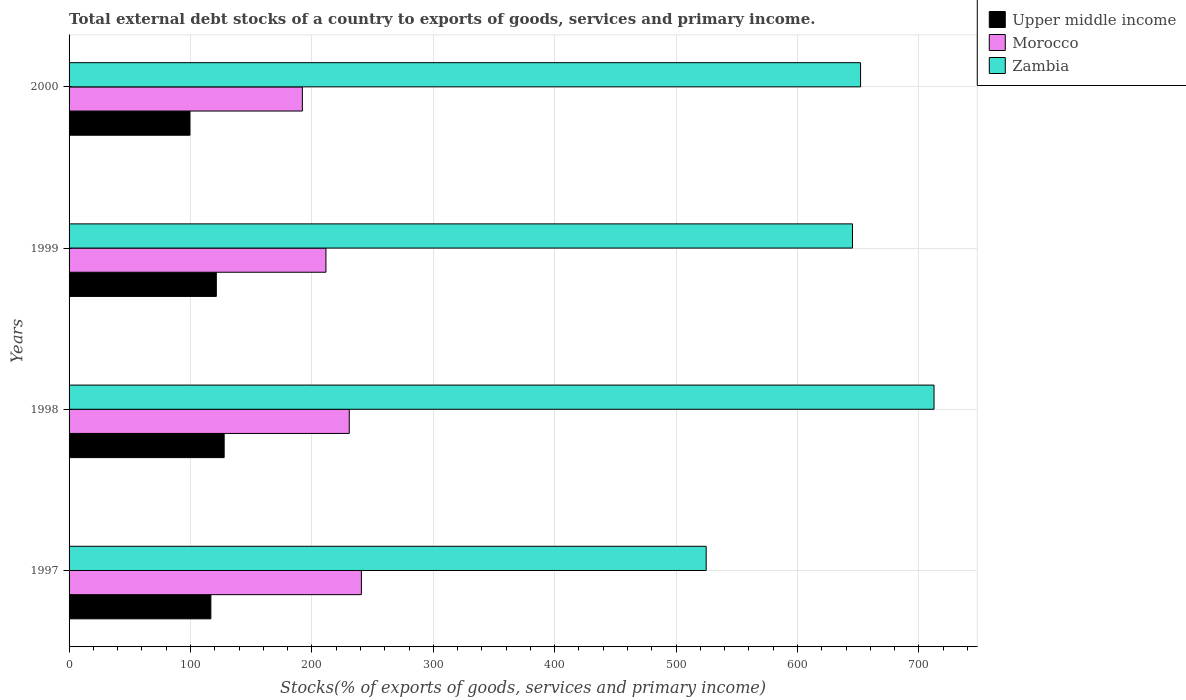How many different coloured bars are there?
Ensure brevity in your answer.  3. How many groups of bars are there?
Make the answer very short. 4. How many bars are there on the 3rd tick from the top?
Offer a very short reply. 3. How many bars are there on the 1st tick from the bottom?
Give a very brief answer. 3. What is the label of the 2nd group of bars from the top?
Provide a succinct answer. 1999. What is the total debt stocks in Morocco in 2000?
Your response must be concise. 192.17. Across all years, what is the maximum total debt stocks in Upper middle income?
Provide a short and direct response. 127.75. Across all years, what is the minimum total debt stocks in Zambia?
Ensure brevity in your answer.  524.81. In which year was the total debt stocks in Morocco maximum?
Your answer should be compact. 1997. In which year was the total debt stocks in Morocco minimum?
Provide a short and direct response. 2000. What is the total total debt stocks in Upper middle income in the graph?
Give a very brief answer. 465.4. What is the difference between the total debt stocks in Morocco in 1997 and that in 2000?
Provide a succinct answer. 48.61. What is the difference between the total debt stocks in Morocco in 2000 and the total debt stocks in Zambia in 1997?
Ensure brevity in your answer.  -332.64. What is the average total debt stocks in Morocco per year?
Keep it short and to the point. 218.83. In the year 1999, what is the difference between the total debt stocks in Morocco and total debt stocks in Zambia?
Offer a terse response. -433.74. In how many years, is the total debt stocks in Zambia greater than 140 %?
Make the answer very short. 4. What is the ratio of the total debt stocks in Morocco in 1999 to that in 2000?
Your answer should be compact. 1.1. Is the total debt stocks in Upper middle income in 1997 less than that in 1999?
Your response must be concise. Yes. What is the difference between the highest and the second highest total debt stocks in Upper middle income?
Your answer should be very brief. 6.46. What is the difference between the highest and the lowest total debt stocks in Morocco?
Offer a terse response. 48.61. In how many years, is the total debt stocks in Zambia greater than the average total debt stocks in Zambia taken over all years?
Your answer should be compact. 3. Is the sum of the total debt stocks in Zambia in 1997 and 2000 greater than the maximum total debt stocks in Upper middle income across all years?
Offer a terse response. Yes. What does the 1st bar from the top in 2000 represents?
Ensure brevity in your answer.  Zambia. What does the 1st bar from the bottom in 2000 represents?
Provide a short and direct response. Upper middle income. Are all the bars in the graph horizontal?
Your answer should be compact. Yes. How many years are there in the graph?
Provide a succinct answer. 4. What is the difference between two consecutive major ticks on the X-axis?
Make the answer very short. 100. Are the values on the major ticks of X-axis written in scientific E-notation?
Provide a succinct answer. No. Does the graph contain any zero values?
Offer a very short reply. No. Does the graph contain grids?
Ensure brevity in your answer.  Yes. Where does the legend appear in the graph?
Your answer should be compact. Top right. What is the title of the graph?
Provide a succinct answer. Total external debt stocks of a country to exports of goods, services and primary income. What is the label or title of the X-axis?
Provide a succinct answer. Stocks(% of exports of goods, services and primary income). What is the Stocks(% of exports of goods, services and primary income) of Upper middle income in 1997?
Offer a very short reply. 116.79. What is the Stocks(% of exports of goods, services and primary income) of Morocco in 1997?
Offer a very short reply. 240.78. What is the Stocks(% of exports of goods, services and primary income) in Zambia in 1997?
Provide a short and direct response. 524.81. What is the Stocks(% of exports of goods, services and primary income) in Upper middle income in 1998?
Offer a terse response. 127.75. What is the Stocks(% of exports of goods, services and primary income) in Morocco in 1998?
Provide a succinct answer. 230.8. What is the Stocks(% of exports of goods, services and primary income) of Zambia in 1998?
Your response must be concise. 712.48. What is the Stocks(% of exports of goods, services and primary income) of Upper middle income in 1999?
Provide a succinct answer. 121.29. What is the Stocks(% of exports of goods, services and primary income) of Morocco in 1999?
Offer a terse response. 211.58. What is the Stocks(% of exports of goods, services and primary income) of Zambia in 1999?
Your answer should be very brief. 645.32. What is the Stocks(% of exports of goods, services and primary income) in Upper middle income in 2000?
Offer a very short reply. 99.57. What is the Stocks(% of exports of goods, services and primary income) in Morocco in 2000?
Offer a very short reply. 192.17. What is the Stocks(% of exports of goods, services and primary income) of Zambia in 2000?
Your answer should be compact. 651.97. Across all years, what is the maximum Stocks(% of exports of goods, services and primary income) in Upper middle income?
Ensure brevity in your answer.  127.75. Across all years, what is the maximum Stocks(% of exports of goods, services and primary income) in Morocco?
Provide a succinct answer. 240.78. Across all years, what is the maximum Stocks(% of exports of goods, services and primary income) in Zambia?
Make the answer very short. 712.48. Across all years, what is the minimum Stocks(% of exports of goods, services and primary income) in Upper middle income?
Keep it short and to the point. 99.57. Across all years, what is the minimum Stocks(% of exports of goods, services and primary income) in Morocco?
Your answer should be very brief. 192.17. Across all years, what is the minimum Stocks(% of exports of goods, services and primary income) of Zambia?
Keep it short and to the point. 524.81. What is the total Stocks(% of exports of goods, services and primary income) in Upper middle income in the graph?
Offer a terse response. 465.4. What is the total Stocks(% of exports of goods, services and primary income) in Morocco in the graph?
Offer a terse response. 875.34. What is the total Stocks(% of exports of goods, services and primary income) in Zambia in the graph?
Your response must be concise. 2534.58. What is the difference between the Stocks(% of exports of goods, services and primary income) in Upper middle income in 1997 and that in 1998?
Your answer should be very brief. -10.96. What is the difference between the Stocks(% of exports of goods, services and primary income) of Morocco in 1997 and that in 1998?
Your response must be concise. 9.99. What is the difference between the Stocks(% of exports of goods, services and primary income) in Zambia in 1997 and that in 1998?
Offer a very short reply. -187.67. What is the difference between the Stocks(% of exports of goods, services and primary income) in Upper middle income in 1997 and that in 1999?
Your response must be concise. -4.51. What is the difference between the Stocks(% of exports of goods, services and primary income) of Morocco in 1997 and that in 1999?
Your response must be concise. 29.2. What is the difference between the Stocks(% of exports of goods, services and primary income) of Zambia in 1997 and that in 1999?
Offer a terse response. -120.51. What is the difference between the Stocks(% of exports of goods, services and primary income) of Upper middle income in 1997 and that in 2000?
Provide a short and direct response. 17.22. What is the difference between the Stocks(% of exports of goods, services and primary income) of Morocco in 1997 and that in 2000?
Keep it short and to the point. 48.61. What is the difference between the Stocks(% of exports of goods, services and primary income) in Zambia in 1997 and that in 2000?
Your answer should be very brief. -127.16. What is the difference between the Stocks(% of exports of goods, services and primary income) of Upper middle income in 1998 and that in 1999?
Provide a short and direct response. 6.46. What is the difference between the Stocks(% of exports of goods, services and primary income) of Morocco in 1998 and that in 1999?
Offer a very short reply. 19.22. What is the difference between the Stocks(% of exports of goods, services and primary income) of Zambia in 1998 and that in 1999?
Keep it short and to the point. 67.16. What is the difference between the Stocks(% of exports of goods, services and primary income) in Upper middle income in 1998 and that in 2000?
Ensure brevity in your answer.  28.18. What is the difference between the Stocks(% of exports of goods, services and primary income) in Morocco in 1998 and that in 2000?
Provide a succinct answer. 38.63. What is the difference between the Stocks(% of exports of goods, services and primary income) in Zambia in 1998 and that in 2000?
Your answer should be compact. 60.51. What is the difference between the Stocks(% of exports of goods, services and primary income) in Upper middle income in 1999 and that in 2000?
Offer a very short reply. 21.72. What is the difference between the Stocks(% of exports of goods, services and primary income) of Morocco in 1999 and that in 2000?
Offer a very short reply. 19.41. What is the difference between the Stocks(% of exports of goods, services and primary income) in Zambia in 1999 and that in 2000?
Ensure brevity in your answer.  -6.65. What is the difference between the Stocks(% of exports of goods, services and primary income) in Upper middle income in 1997 and the Stocks(% of exports of goods, services and primary income) in Morocco in 1998?
Provide a succinct answer. -114.01. What is the difference between the Stocks(% of exports of goods, services and primary income) of Upper middle income in 1997 and the Stocks(% of exports of goods, services and primary income) of Zambia in 1998?
Offer a terse response. -595.69. What is the difference between the Stocks(% of exports of goods, services and primary income) of Morocco in 1997 and the Stocks(% of exports of goods, services and primary income) of Zambia in 1998?
Keep it short and to the point. -471.69. What is the difference between the Stocks(% of exports of goods, services and primary income) of Upper middle income in 1997 and the Stocks(% of exports of goods, services and primary income) of Morocco in 1999?
Your answer should be very brief. -94.79. What is the difference between the Stocks(% of exports of goods, services and primary income) in Upper middle income in 1997 and the Stocks(% of exports of goods, services and primary income) in Zambia in 1999?
Keep it short and to the point. -528.53. What is the difference between the Stocks(% of exports of goods, services and primary income) in Morocco in 1997 and the Stocks(% of exports of goods, services and primary income) in Zambia in 1999?
Your answer should be compact. -404.53. What is the difference between the Stocks(% of exports of goods, services and primary income) of Upper middle income in 1997 and the Stocks(% of exports of goods, services and primary income) of Morocco in 2000?
Your response must be concise. -75.39. What is the difference between the Stocks(% of exports of goods, services and primary income) of Upper middle income in 1997 and the Stocks(% of exports of goods, services and primary income) of Zambia in 2000?
Make the answer very short. -535.18. What is the difference between the Stocks(% of exports of goods, services and primary income) in Morocco in 1997 and the Stocks(% of exports of goods, services and primary income) in Zambia in 2000?
Keep it short and to the point. -411.19. What is the difference between the Stocks(% of exports of goods, services and primary income) of Upper middle income in 1998 and the Stocks(% of exports of goods, services and primary income) of Morocco in 1999?
Give a very brief answer. -83.83. What is the difference between the Stocks(% of exports of goods, services and primary income) in Upper middle income in 1998 and the Stocks(% of exports of goods, services and primary income) in Zambia in 1999?
Offer a very short reply. -517.57. What is the difference between the Stocks(% of exports of goods, services and primary income) in Morocco in 1998 and the Stocks(% of exports of goods, services and primary income) in Zambia in 1999?
Give a very brief answer. -414.52. What is the difference between the Stocks(% of exports of goods, services and primary income) of Upper middle income in 1998 and the Stocks(% of exports of goods, services and primary income) of Morocco in 2000?
Give a very brief answer. -64.42. What is the difference between the Stocks(% of exports of goods, services and primary income) of Upper middle income in 1998 and the Stocks(% of exports of goods, services and primary income) of Zambia in 2000?
Offer a terse response. -524.22. What is the difference between the Stocks(% of exports of goods, services and primary income) of Morocco in 1998 and the Stocks(% of exports of goods, services and primary income) of Zambia in 2000?
Make the answer very short. -421.17. What is the difference between the Stocks(% of exports of goods, services and primary income) of Upper middle income in 1999 and the Stocks(% of exports of goods, services and primary income) of Morocco in 2000?
Your answer should be compact. -70.88. What is the difference between the Stocks(% of exports of goods, services and primary income) in Upper middle income in 1999 and the Stocks(% of exports of goods, services and primary income) in Zambia in 2000?
Your response must be concise. -530.68. What is the difference between the Stocks(% of exports of goods, services and primary income) in Morocco in 1999 and the Stocks(% of exports of goods, services and primary income) in Zambia in 2000?
Your answer should be compact. -440.39. What is the average Stocks(% of exports of goods, services and primary income) in Upper middle income per year?
Make the answer very short. 116.35. What is the average Stocks(% of exports of goods, services and primary income) in Morocco per year?
Keep it short and to the point. 218.83. What is the average Stocks(% of exports of goods, services and primary income) of Zambia per year?
Your response must be concise. 633.64. In the year 1997, what is the difference between the Stocks(% of exports of goods, services and primary income) in Upper middle income and Stocks(% of exports of goods, services and primary income) in Morocco?
Your answer should be very brief. -124. In the year 1997, what is the difference between the Stocks(% of exports of goods, services and primary income) in Upper middle income and Stocks(% of exports of goods, services and primary income) in Zambia?
Your answer should be very brief. -408.02. In the year 1997, what is the difference between the Stocks(% of exports of goods, services and primary income) of Morocco and Stocks(% of exports of goods, services and primary income) of Zambia?
Your answer should be very brief. -284.03. In the year 1998, what is the difference between the Stocks(% of exports of goods, services and primary income) of Upper middle income and Stocks(% of exports of goods, services and primary income) of Morocco?
Your response must be concise. -103.05. In the year 1998, what is the difference between the Stocks(% of exports of goods, services and primary income) of Upper middle income and Stocks(% of exports of goods, services and primary income) of Zambia?
Your answer should be compact. -584.73. In the year 1998, what is the difference between the Stocks(% of exports of goods, services and primary income) in Morocco and Stocks(% of exports of goods, services and primary income) in Zambia?
Offer a terse response. -481.68. In the year 1999, what is the difference between the Stocks(% of exports of goods, services and primary income) of Upper middle income and Stocks(% of exports of goods, services and primary income) of Morocco?
Provide a short and direct response. -90.29. In the year 1999, what is the difference between the Stocks(% of exports of goods, services and primary income) in Upper middle income and Stocks(% of exports of goods, services and primary income) in Zambia?
Ensure brevity in your answer.  -524.02. In the year 1999, what is the difference between the Stocks(% of exports of goods, services and primary income) of Morocco and Stocks(% of exports of goods, services and primary income) of Zambia?
Offer a terse response. -433.74. In the year 2000, what is the difference between the Stocks(% of exports of goods, services and primary income) of Upper middle income and Stocks(% of exports of goods, services and primary income) of Morocco?
Your response must be concise. -92.6. In the year 2000, what is the difference between the Stocks(% of exports of goods, services and primary income) in Upper middle income and Stocks(% of exports of goods, services and primary income) in Zambia?
Your answer should be very brief. -552.4. In the year 2000, what is the difference between the Stocks(% of exports of goods, services and primary income) of Morocco and Stocks(% of exports of goods, services and primary income) of Zambia?
Your answer should be very brief. -459.8. What is the ratio of the Stocks(% of exports of goods, services and primary income) of Upper middle income in 1997 to that in 1998?
Provide a short and direct response. 0.91. What is the ratio of the Stocks(% of exports of goods, services and primary income) in Morocco in 1997 to that in 1998?
Make the answer very short. 1.04. What is the ratio of the Stocks(% of exports of goods, services and primary income) in Zambia in 1997 to that in 1998?
Your answer should be very brief. 0.74. What is the ratio of the Stocks(% of exports of goods, services and primary income) in Upper middle income in 1997 to that in 1999?
Your answer should be compact. 0.96. What is the ratio of the Stocks(% of exports of goods, services and primary income) in Morocco in 1997 to that in 1999?
Your answer should be very brief. 1.14. What is the ratio of the Stocks(% of exports of goods, services and primary income) in Zambia in 1997 to that in 1999?
Provide a short and direct response. 0.81. What is the ratio of the Stocks(% of exports of goods, services and primary income) of Upper middle income in 1997 to that in 2000?
Your answer should be very brief. 1.17. What is the ratio of the Stocks(% of exports of goods, services and primary income) of Morocco in 1997 to that in 2000?
Your response must be concise. 1.25. What is the ratio of the Stocks(% of exports of goods, services and primary income) of Zambia in 1997 to that in 2000?
Make the answer very short. 0.81. What is the ratio of the Stocks(% of exports of goods, services and primary income) in Upper middle income in 1998 to that in 1999?
Your answer should be compact. 1.05. What is the ratio of the Stocks(% of exports of goods, services and primary income) in Morocco in 1998 to that in 1999?
Provide a short and direct response. 1.09. What is the ratio of the Stocks(% of exports of goods, services and primary income) of Zambia in 1998 to that in 1999?
Your answer should be compact. 1.1. What is the ratio of the Stocks(% of exports of goods, services and primary income) in Upper middle income in 1998 to that in 2000?
Ensure brevity in your answer.  1.28. What is the ratio of the Stocks(% of exports of goods, services and primary income) of Morocco in 1998 to that in 2000?
Provide a short and direct response. 1.2. What is the ratio of the Stocks(% of exports of goods, services and primary income) in Zambia in 1998 to that in 2000?
Your answer should be very brief. 1.09. What is the ratio of the Stocks(% of exports of goods, services and primary income) of Upper middle income in 1999 to that in 2000?
Offer a very short reply. 1.22. What is the ratio of the Stocks(% of exports of goods, services and primary income) of Morocco in 1999 to that in 2000?
Give a very brief answer. 1.1. What is the ratio of the Stocks(% of exports of goods, services and primary income) of Zambia in 1999 to that in 2000?
Offer a terse response. 0.99. What is the difference between the highest and the second highest Stocks(% of exports of goods, services and primary income) of Upper middle income?
Keep it short and to the point. 6.46. What is the difference between the highest and the second highest Stocks(% of exports of goods, services and primary income) in Morocco?
Offer a very short reply. 9.99. What is the difference between the highest and the second highest Stocks(% of exports of goods, services and primary income) in Zambia?
Give a very brief answer. 60.51. What is the difference between the highest and the lowest Stocks(% of exports of goods, services and primary income) of Upper middle income?
Ensure brevity in your answer.  28.18. What is the difference between the highest and the lowest Stocks(% of exports of goods, services and primary income) in Morocco?
Make the answer very short. 48.61. What is the difference between the highest and the lowest Stocks(% of exports of goods, services and primary income) in Zambia?
Provide a short and direct response. 187.67. 